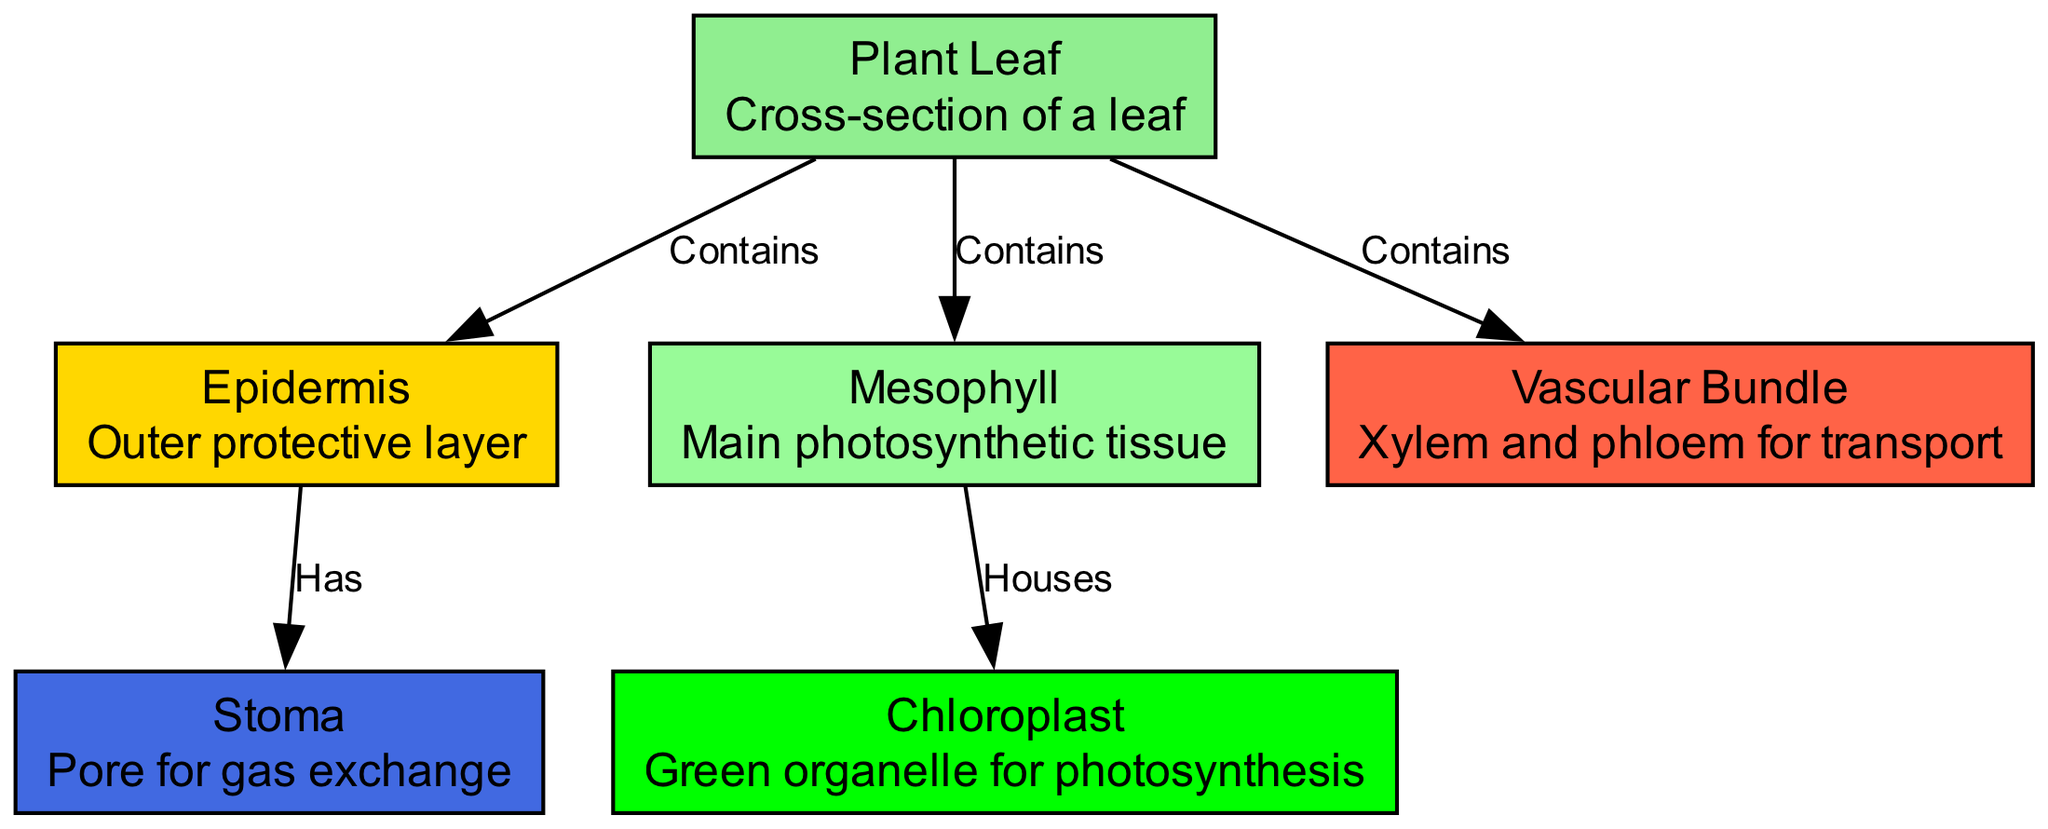What is the outer layer of the leaf called? The diagram identifies the outer protective layer of the leaf as the "Epidermis." This information is labeled directly in the node corresponding to the epidermis.
Answer: Epidermis How many main components are identified in the leaf structure? The diagram presents three main components of the leaf structure: epidermis, mesophyll, and vascular bundle, as noted in the respective nodes. Therefore, the total count is three components.
Answer: 3 Which part houses chloroplasts? The diagram indicates that the "Mesophyll" is the part that houses chloroplasts, as shown by the relationship between the mesophyll and chloroplast nodes via the label "Houses."
Answer: Mesophyll What does the stoma do? According to the diagram, the stoma serves as a pore for gas exchange, as defined in the node description associated with this part.
Answer: Gas exchange Which structure in the leaf contains xylem and phloem? The diagram clearly differentiates that the "Vascular Bundle" contains xylem and phloem, as indicated by the label associated with the vascular bundle node.
Answer: Vascular Bundle What type of cells in the leaf assist in photosynthesis? The diagram specifies that "Chloroplasts" are the green organelles that assist specifically in photosynthesis, as described in the chloroplast node.
Answer: Chloroplast How many edges are present in the diagram? The diagram lists a total of five connections (edges) between nodes: leaf to epidermis, leaf to mesophyll, leaf to vascular bundle, mesophyll to chloroplast, and epidermis to stoma. Therefore, the total count of edges is five.
Answer: 5 What does the epidermis have that aids in gas exchange? The diagram indicates that the epidermis "Has" stoma, which are important for facilitating gas exchange in the leaf. This relationship is described in the edges section of the diagram.
Answer: Stoma What is the purpose of the vascular bundle? The diagram states that the vascular bundle's purpose is for transport, which encompasses the transportation of nutrients through xylem and phloem, as defined in the node description.
Answer: Transport 